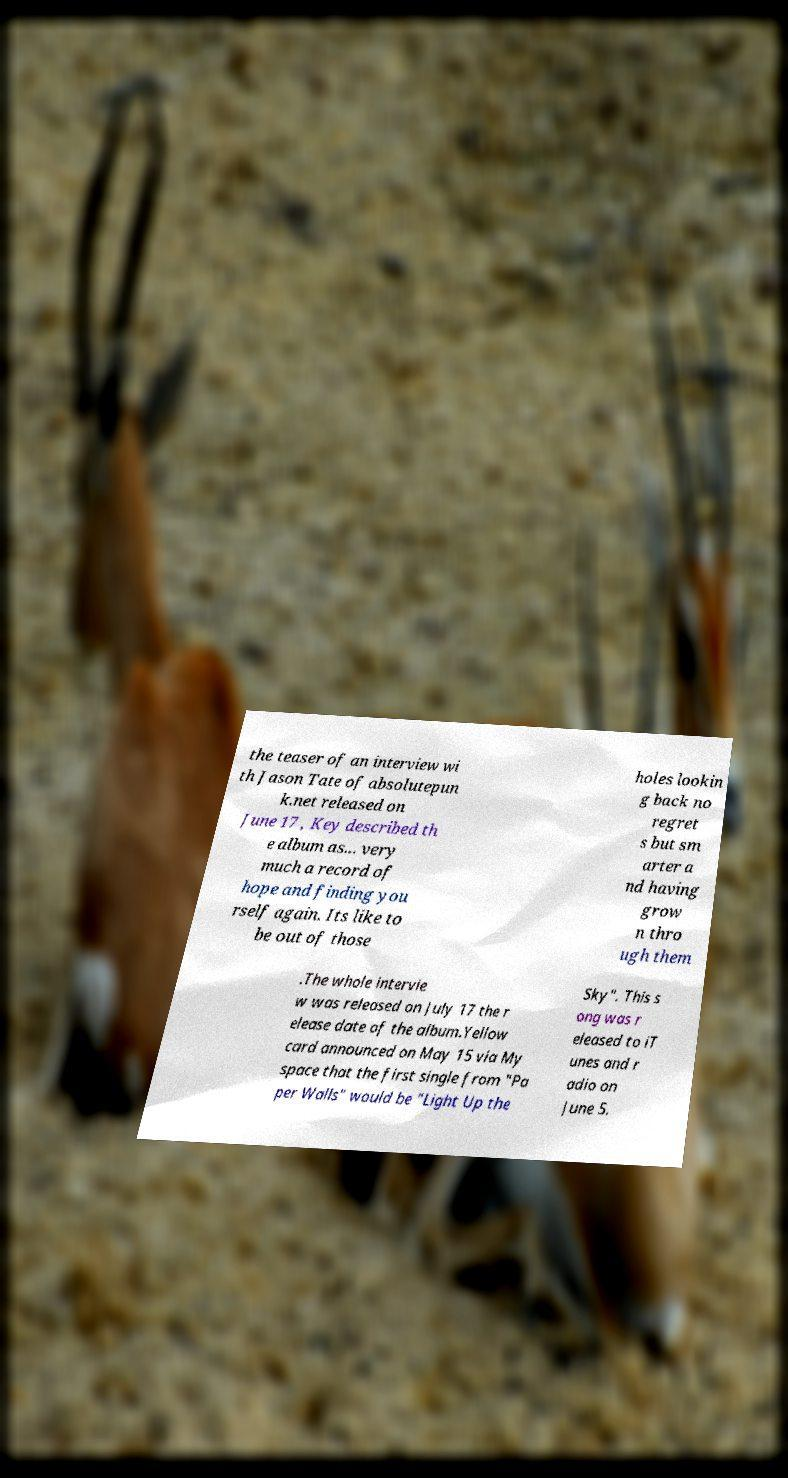For documentation purposes, I need the text within this image transcribed. Could you provide that? the teaser of an interview wi th Jason Tate of absolutepun k.net released on June 17 , Key described th e album as... very much a record of hope and finding you rself again. Its like to be out of those holes lookin g back no regret s but sm arter a nd having grow n thro ugh them .The whole intervie w was released on July 17 the r elease date of the album.Yellow card announced on May 15 via My space that the first single from "Pa per Walls" would be "Light Up the Sky". This s ong was r eleased to iT unes and r adio on June 5. 